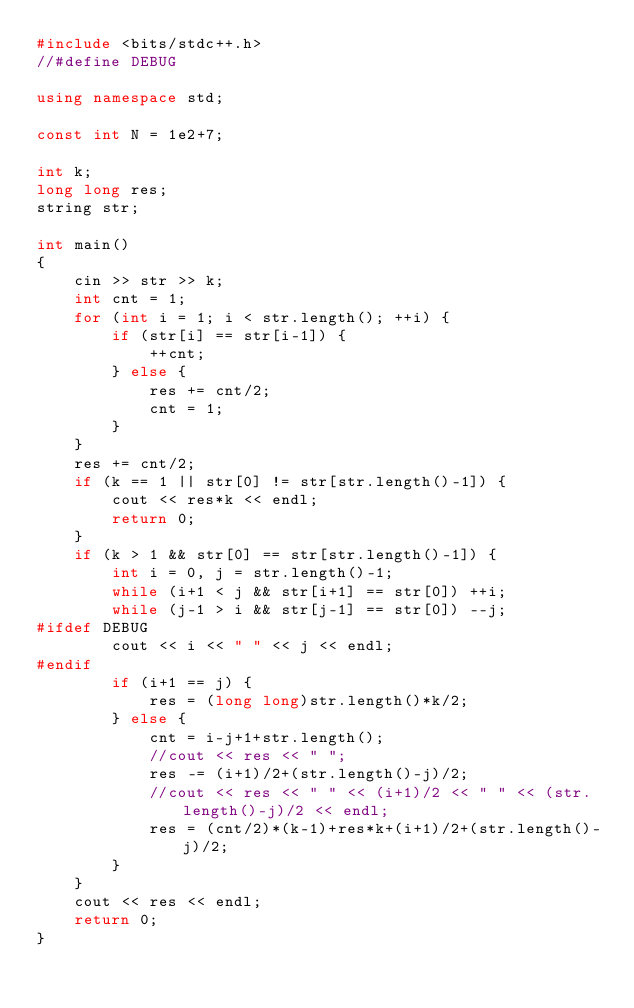Convert code to text. <code><loc_0><loc_0><loc_500><loc_500><_C++_>#include <bits/stdc++.h>
//#define DEBUG

using namespace std;

const int N = 1e2+7;

int k;
long long res;
string str;

int main()
{
    cin >> str >> k;
    int cnt = 1;
    for (int i = 1; i < str.length(); ++i) {
        if (str[i] == str[i-1]) {
            ++cnt;
        } else {
            res += cnt/2;
            cnt = 1;
        }
    }
    res += cnt/2;
    if (k == 1 || str[0] != str[str.length()-1]) {
        cout << res*k << endl;
        return 0;
    }
    if (k > 1 && str[0] == str[str.length()-1]) {
        int i = 0, j = str.length()-1;
        while (i+1 < j && str[i+1] == str[0]) ++i;
        while (j-1 > i && str[j-1] == str[0]) --j;
#ifdef DEBUG
        cout << i << " " << j << endl;
#endif
        if (i+1 == j) {
            res = (long long)str.length()*k/2;
        } else {
            cnt = i-j+1+str.length();
            //cout << res << " ";
            res -= (i+1)/2+(str.length()-j)/2;
            //cout << res << " " << (i+1)/2 << " " << (str.length()-j)/2 << endl;
            res = (cnt/2)*(k-1)+res*k+(i+1)/2+(str.length()-j)/2;
        }
    }
    cout << res << endl;
    return 0;
}
</code> 